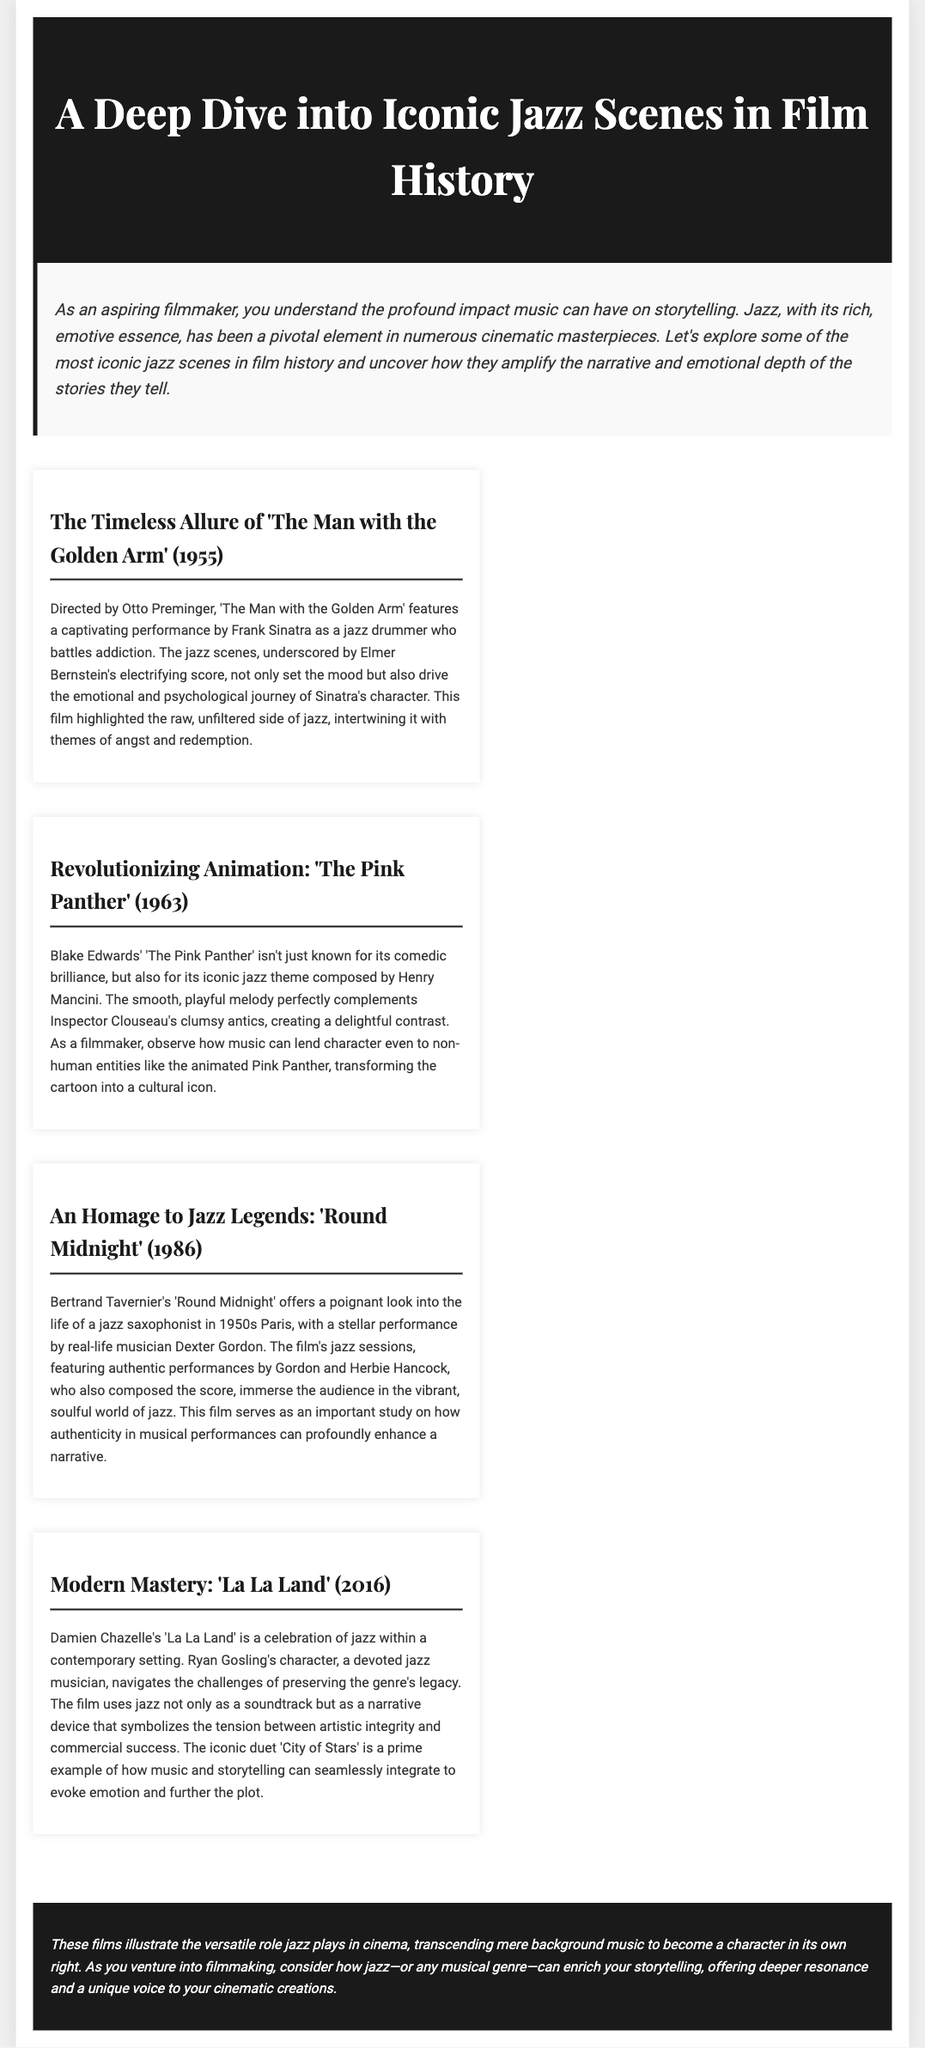what is the title of the magazine? The title of the magazine is prominently displayed in the header section of the document.
Answer: A Deep Dive into Iconic Jazz Scenes in Film History who directed 'The Man with the Golden Arm'? The document cites Otto Preminger as the director of the film.
Answer: Otto Preminger which actor is featured in 'Round Midnight'? The performance in 'Round Midnight' is highlighted as being by Dexter Gordon.
Answer: Dexter Gordon what year was 'La La Land' released? The document includes the release year of 'La La Land' in its content.
Answer: 2016 what is a primary theme discussed in 'La La Land'? The theme discussed involves the tension between artistic integrity and commercial success.
Answer: Artistic integrity and commercial success how does jazz function in these films according to the conclusion? The conclusion indicates that jazz transcends background music to become a character in its own right.
Answer: A character in its own right who composed the score for 'Round Midnight'? The document states that Herbie Hancock composed the score for this film.
Answer: Herbie Hancock what type of melody is associated with 'The Pink Panther'? The document describes the melody as smooth and playful.
Answer: Smooth and playful 